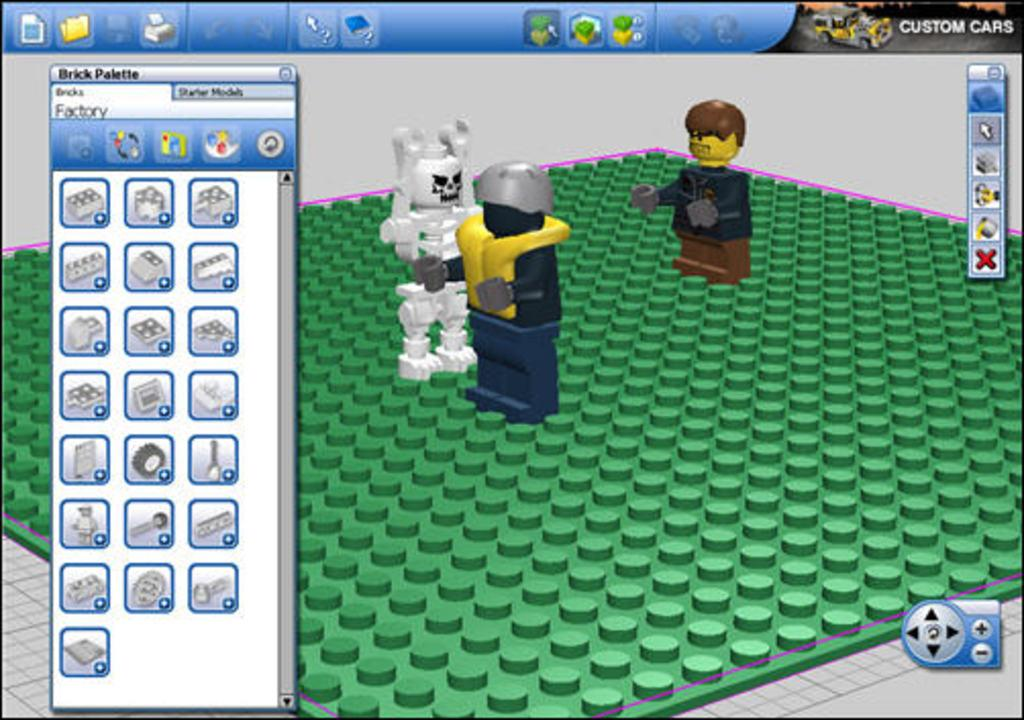<image>
Present a compact description of the photo's key features. Three d lego people on a green lego board with the words Custom Cars to the top right. 